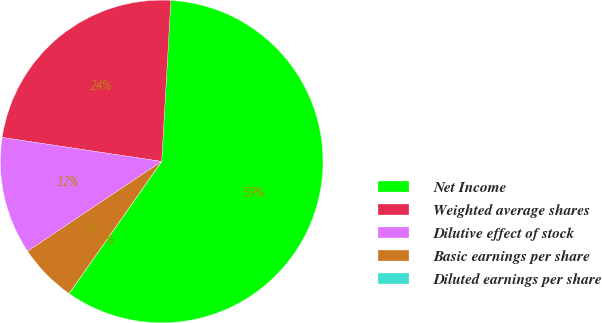Convert chart to OTSL. <chart><loc_0><loc_0><loc_500><loc_500><pie_chart><fcel>Net Income<fcel>Weighted average shares<fcel>Dilutive effect of stock<fcel>Basic earnings per share<fcel>Diluted earnings per share<nl><fcel>58.82%<fcel>23.53%<fcel>11.77%<fcel>5.88%<fcel>0.0%<nl></chart> 